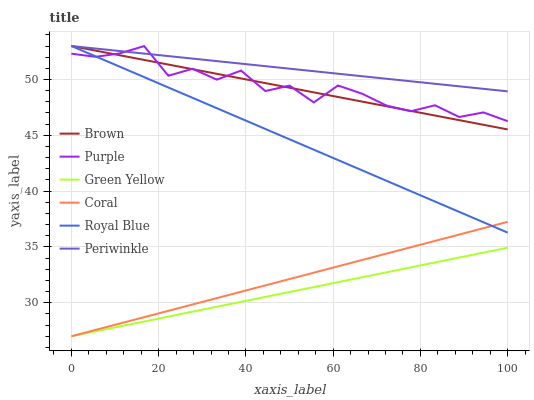Does Green Yellow have the minimum area under the curve?
Answer yes or no. Yes. Does Periwinkle have the maximum area under the curve?
Answer yes or no. Yes. Does Purple have the minimum area under the curve?
Answer yes or no. No. Does Purple have the maximum area under the curve?
Answer yes or no. No. Is Coral the smoothest?
Answer yes or no. Yes. Is Purple the roughest?
Answer yes or no. Yes. Is Purple the smoothest?
Answer yes or no. No. Is Coral the roughest?
Answer yes or no. No. Does Purple have the lowest value?
Answer yes or no. No. Does Periwinkle have the highest value?
Answer yes or no. Yes. Does Purple have the highest value?
Answer yes or no. No. Is Green Yellow less than Purple?
Answer yes or no. Yes. Is Periwinkle greater than Green Yellow?
Answer yes or no. Yes. Does Periwinkle intersect Royal Blue?
Answer yes or no. Yes. Is Periwinkle less than Royal Blue?
Answer yes or no. No. Is Periwinkle greater than Royal Blue?
Answer yes or no. No. Does Green Yellow intersect Purple?
Answer yes or no. No. 